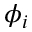Convert formula to latex. <formula><loc_0><loc_0><loc_500><loc_500>\phi _ { i }</formula> 